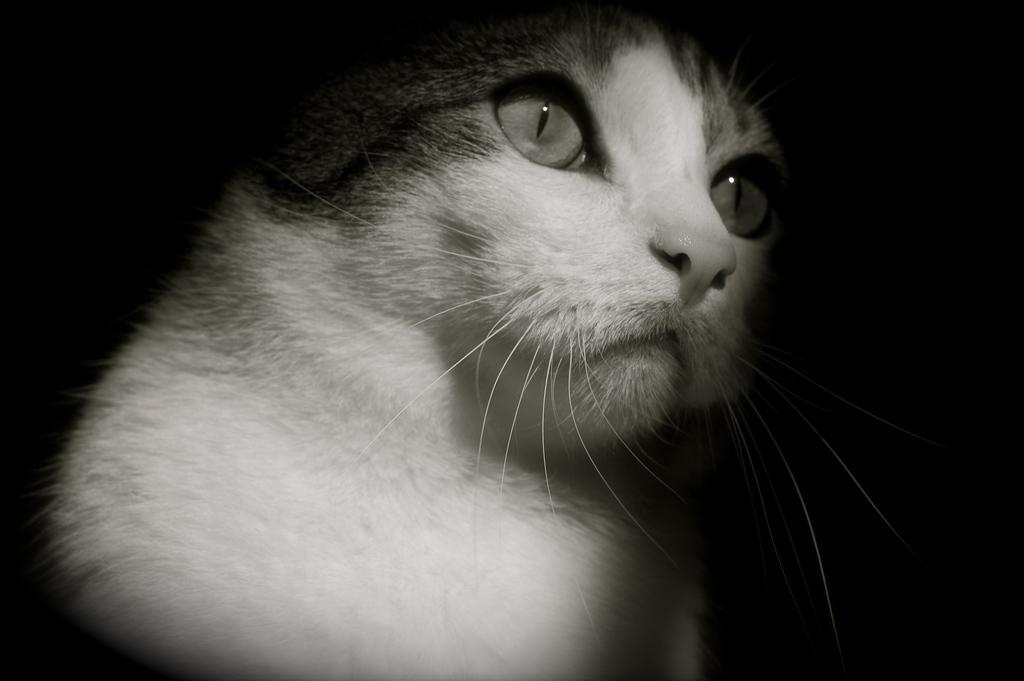Describe this image in one or two sentences. It is the black and white image in which we can see there is a cat in the middle. 